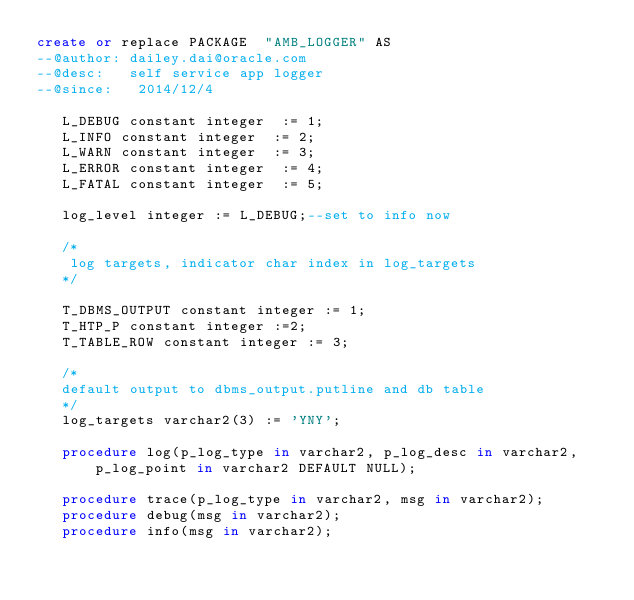<code> <loc_0><loc_0><loc_500><loc_500><_SQL_>create or replace PACKAGE  "AMB_LOGGER" AS  
--@author: dailey.dai@oracle.com  
--@desc:   self service app logger  
--@since:   2014/12/4  
     
   L_DEBUG constant integer  := 1;  
   L_INFO constant integer  := 2;  
   L_WARN constant integer  := 3;  
   L_ERROR constant integer  := 4;  
   L_FATAL constant integer  := 5;  
     
   log_level integer := L_DEBUG;--set to info now  
     
   /*  
    log targets, indicator char index in log_targets  
   */  
     
   T_DBMS_OUTPUT constant integer := 1;  
   T_HTP_P constant integer :=2;  
   T_TABLE_ROW constant integer := 3;  
     
   /*  
   default output to dbms_output.putline and db table  
   */  
   log_targets varchar2(3) := 'YNY';  
     
   procedure log(p_log_type in varchar2, p_log_desc in varchar2,p_log_point in varchar2 DEFAULT NULL);  
     
   procedure trace(p_log_type in varchar2, msg in varchar2);  
   procedure debug(msg in varchar2);  
   procedure info(msg in varchar2);  </code> 